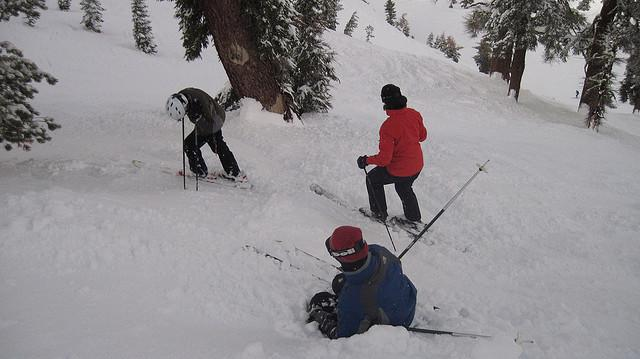How did the person wearing blue come to be in the position they are in? skiing 